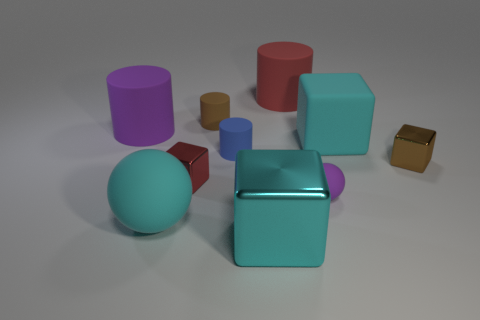Subtract all tiny red blocks. How many blocks are left? 3 Subtract all purple balls. How many cyan blocks are left? 2 Subtract all brown cylinders. How many cylinders are left? 3 Subtract all cubes. How many objects are left? 6 Subtract 0 green cylinders. How many objects are left? 10 Subtract 1 spheres. How many spheres are left? 1 Subtract all blue cylinders. Subtract all blue cubes. How many cylinders are left? 3 Subtract all purple cylinders. Subtract all brown shiny cubes. How many objects are left? 8 Add 7 brown things. How many brown things are left? 9 Add 10 small green shiny cylinders. How many small green shiny cylinders exist? 10 